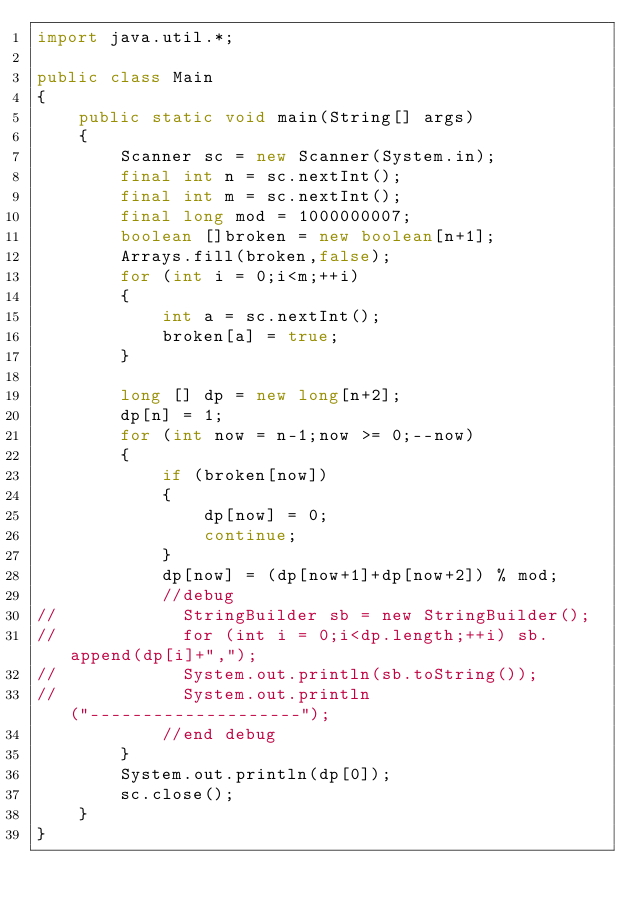<code> <loc_0><loc_0><loc_500><loc_500><_Java_>import java.util.*;

public class Main
{
    public static void main(String[] args)
    {
        Scanner sc = new Scanner(System.in);
        final int n = sc.nextInt();
        final int m = sc.nextInt();
        final long mod = 1000000007;
        boolean []broken = new boolean[n+1];
        Arrays.fill(broken,false);
        for (int i = 0;i<m;++i)
        {
            int a = sc.nextInt();
            broken[a] = true;
        }

        long [] dp = new long[n+2];
        dp[n] = 1;
        for (int now = n-1;now >= 0;--now)
        {
            if (broken[now])
            {
                dp[now] = 0;
                continue;
            }
            dp[now] = (dp[now+1]+dp[now+2]) % mod;
            //debug
//            StringBuilder sb = new StringBuilder();
//            for (int i = 0;i<dp.length;++i) sb.append(dp[i]+",");
//            System.out.println(sb.toString());
//            System.out.println("--------------------");
            //end debug
        }
        System.out.println(dp[0]);
        sc.close();
    }
}</code> 